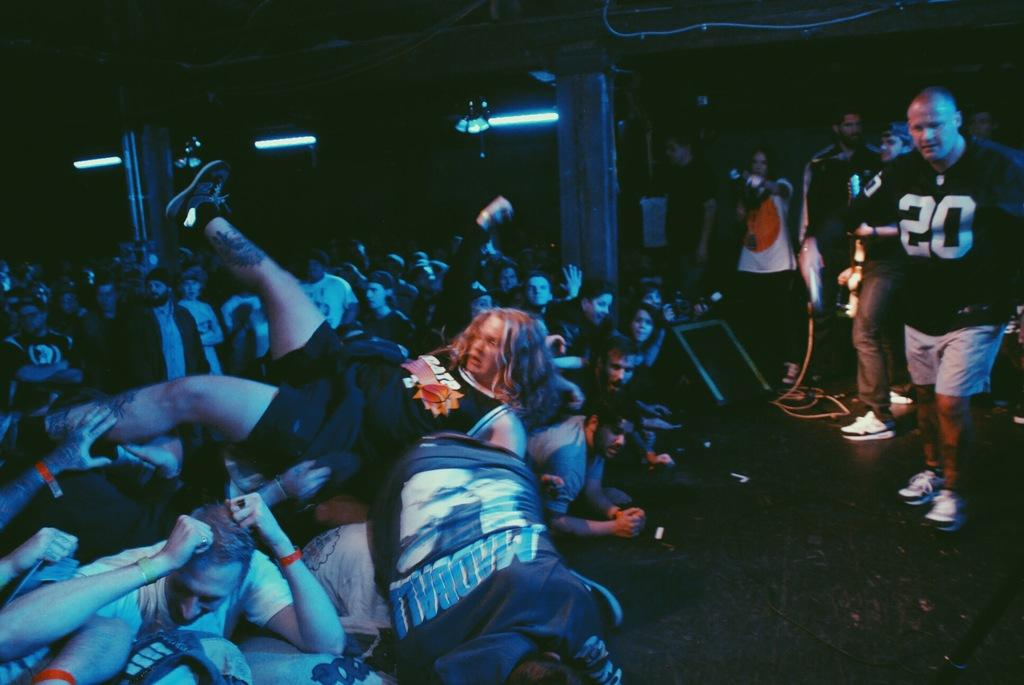<image>
Provide a brief description of the given image. A man stands watching others in a shirt with the number 20 on it. 